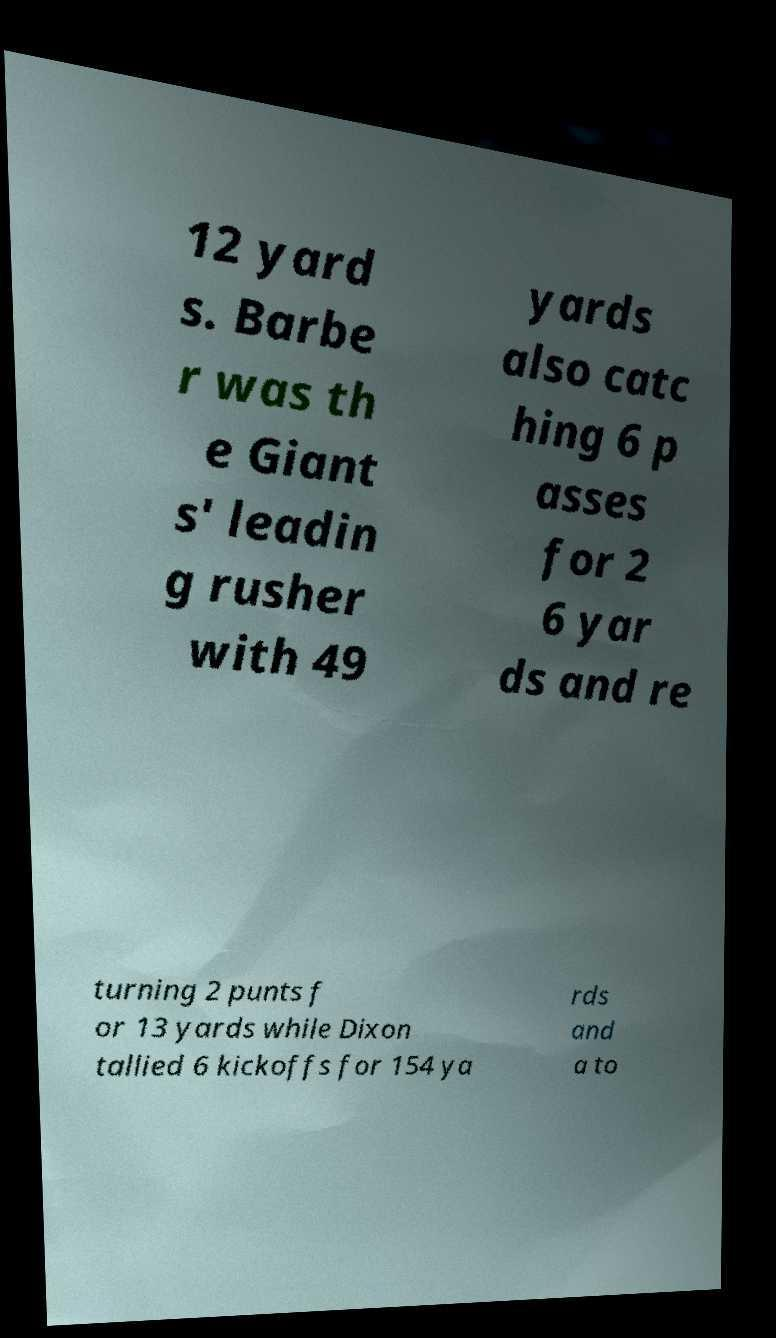Can you read and provide the text displayed in the image?This photo seems to have some interesting text. Can you extract and type it out for me? 12 yard s. Barbe r was th e Giant s' leadin g rusher with 49 yards also catc hing 6 p asses for 2 6 yar ds and re turning 2 punts f or 13 yards while Dixon tallied 6 kickoffs for 154 ya rds and a to 